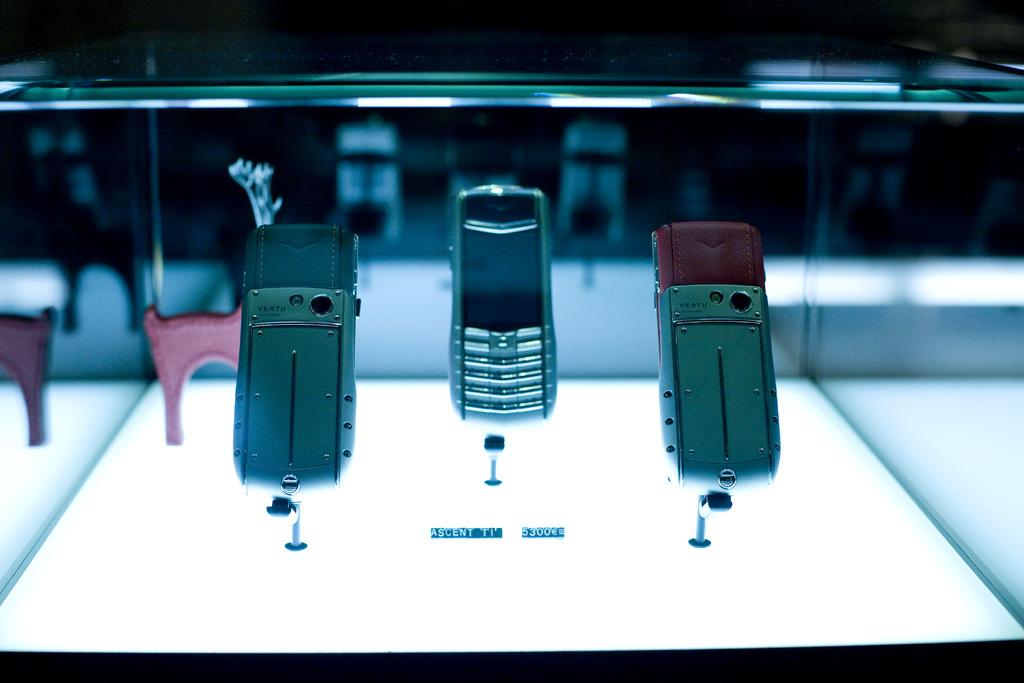Provide a one-sentence caption for the provided image. Three phones on a display shelf made by the company VERTU. 